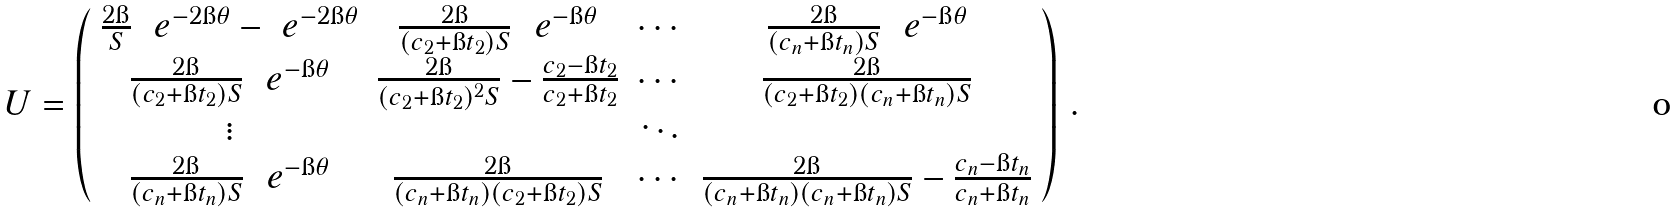Convert formula to latex. <formula><loc_0><loc_0><loc_500><loc_500>U = \left ( \begin{array} { c c c c } \frac { 2 \i } { S } \ \ e ^ { - 2 \i \theta } - \ e ^ { - 2 \i \theta } & \frac { 2 \i } { ( c _ { 2 } + \i t _ { 2 } ) S } \ \ e ^ { - \i \theta } & \cdots & \frac { 2 \i } { ( c _ { n } + \i t _ { n } ) S } \ \ e ^ { - \i \theta } \\ \frac { 2 \i } { ( c _ { 2 } + \i t _ { 2 } ) S } \ \ e ^ { - \i \theta } & \frac { 2 \i } { ( c _ { 2 } + \i t _ { 2 } ) ^ { 2 } S } - \frac { c _ { 2 } - \i t _ { 2 } } { c _ { 2 } + \i t _ { 2 } } & \cdots & \frac { 2 \i } { ( c _ { 2 } + \i t _ { 2 } ) ( c _ { n } + \i t _ { n } ) S } \\ \vdots & & \ddots & \\ \frac { 2 \i } { ( c _ { n } + \i t _ { n } ) S } \ \ e ^ { - \i \theta } & \frac { 2 \i } { ( c _ { n } + \i t _ { n } ) ( c _ { 2 } + \i t _ { 2 } ) S } & \cdots & \frac { 2 \i } { ( c _ { n } + \i t _ { n } ) ( c _ { n } + \i t _ { n } ) S } - \frac { c _ { n } - \i t _ { n } } { c _ { n } + \i t _ { n } } \end{array} \right ) \, .</formula> 